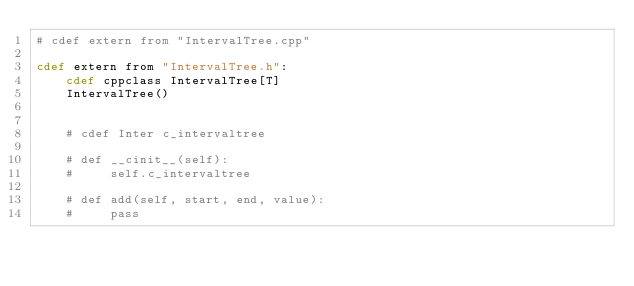<code> <loc_0><loc_0><loc_500><loc_500><_Cython_># cdef extern from "IntervalTree.cpp"

cdef extern from "IntervalTree.h":
    cdef cppclass IntervalTree[T]
    IntervalTree()


    # cdef Inter c_intervaltree

    # def __cinit__(self):
    #     self.c_intervaltree

    # def add(self, start, end, value):
    #     pass
</code> 